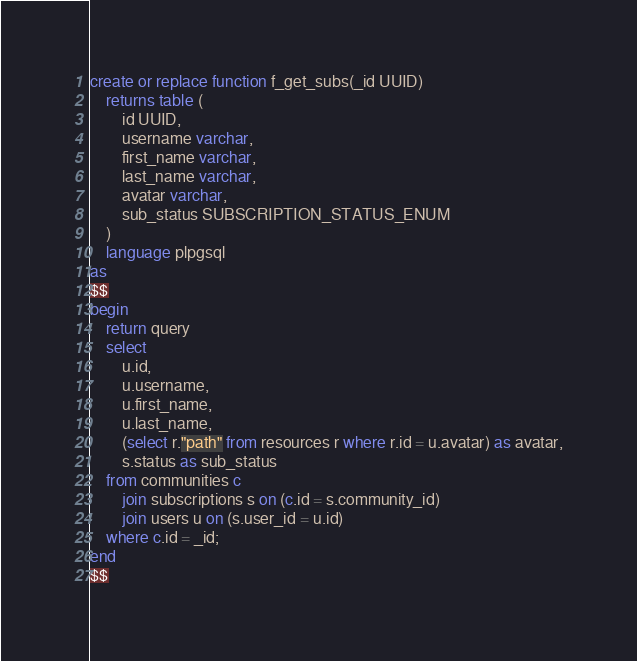<code> <loc_0><loc_0><loc_500><loc_500><_SQL_>create or replace function f_get_subs(_id UUID)
	returns table (
		id UUID,
		username varchar,
		first_name varchar,
		last_name varchar,
		avatar varchar,
		sub_status SUBSCRIPTION_STATUS_ENUM
	)
	language plpgsql
as
$$
begin
	return query
	select
		u.id,
		u.username,
		u.first_name,
		u.last_name,
		(select r."path" from resources r where r.id = u.avatar) as avatar,
		s.status as sub_status
	from communities c 
		join subscriptions s on (c.id = s.community_id)
		join users u on (s.user_id = u.id)
	where c.id = _id;
end
$$</code> 